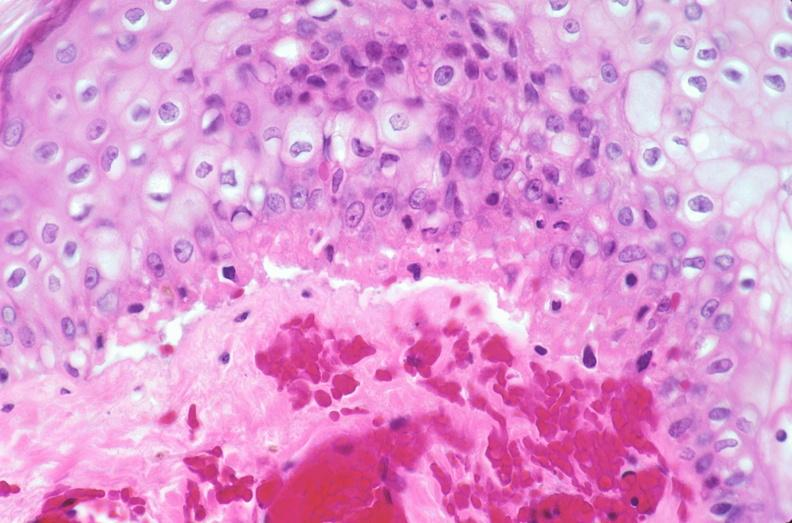does view of knee at autopsy show skin, epidermolysis bullosa?
Answer the question using a single word or phrase. No 